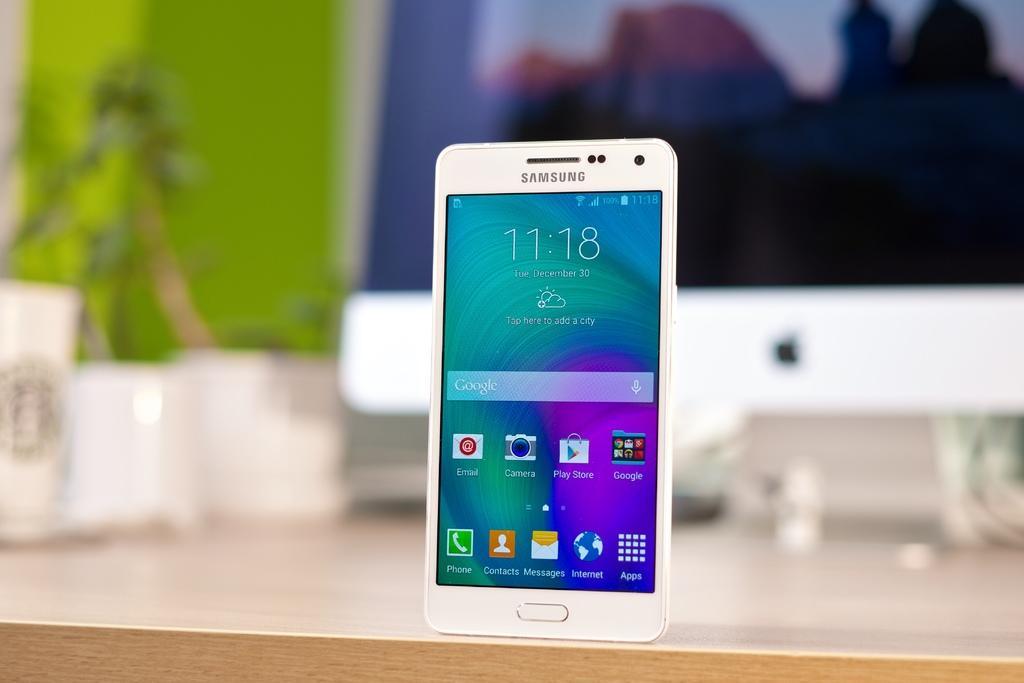How would you summarize this image in a sentence or two? In the center of the picture there is a mobile on a wooden desk. The background is blurred. 